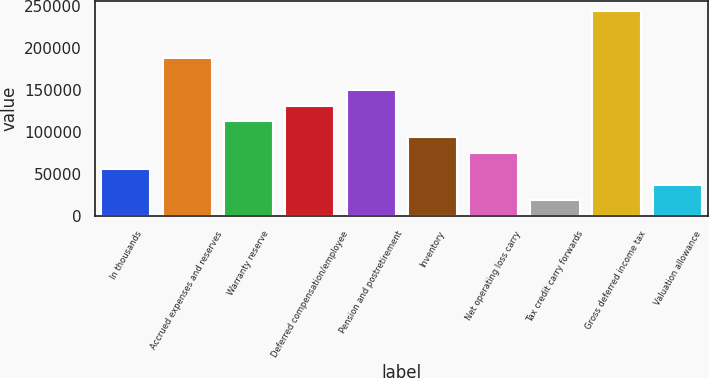<chart> <loc_0><loc_0><loc_500><loc_500><bar_chart><fcel>In thousands<fcel>Accrued expenses and reserves<fcel>Warranty reserve<fcel>Deferred compensation/employee<fcel>Pension and postretirement<fcel>Inventory<fcel>Net operating loss carry<fcel>Tax credit carry forwards<fcel>Gross deferred income tax<fcel>Valuation allowance<nl><fcel>56477.7<fcel>187923<fcel>112811<fcel>131589<fcel>150367<fcel>94033.5<fcel>75255.6<fcel>18921.9<fcel>244257<fcel>37699.8<nl></chart> 